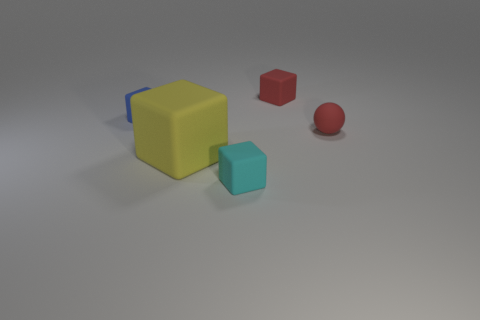The big yellow thing is what shape?
Your answer should be very brief. Cube. Is there a rubber thing that has the same color as the small sphere?
Your answer should be very brief. Yes. Does the matte thing that is left of the yellow rubber thing have the same shape as the tiny red matte thing that is behind the tiny red ball?
Your answer should be compact. Yes. Are there any red balls that have the same material as the blue block?
Provide a succinct answer. Yes. How many brown things are blocks or tiny matte balls?
Make the answer very short. 0. There is a block that is in front of the small blue rubber block and behind the cyan matte block; what size is it?
Make the answer very short. Large. Are there more blocks in front of the red rubber sphere than big red matte cylinders?
Offer a terse response. Yes. How many spheres are either small things or cyan rubber objects?
Your answer should be very brief. 1. What is the shape of the matte object that is both behind the large yellow cube and in front of the blue block?
Ensure brevity in your answer.  Sphere. Are there the same number of small red objects that are on the left side of the blue cube and matte balls behind the yellow block?
Offer a very short reply. No. 